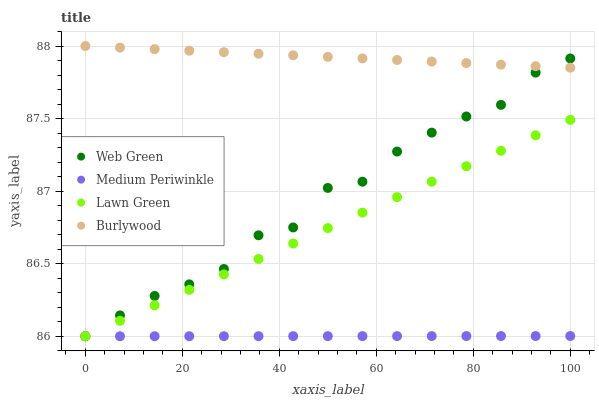Does Medium Periwinkle have the minimum area under the curve?
Answer yes or no. Yes. Does Burlywood have the maximum area under the curve?
Answer yes or no. Yes. Does Lawn Green have the minimum area under the curve?
Answer yes or no. No. Does Lawn Green have the maximum area under the curve?
Answer yes or no. No. Is Medium Periwinkle the smoothest?
Answer yes or no. Yes. Is Web Green the roughest?
Answer yes or no. Yes. Is Lawn Green the smoothest?
Answer yes or no. No. Is Lawn Green the roughest?
Answer yes or no. No. Does Lawn Green have the lowest value?
Answer yes or no. Yes. Does Burlywood have the highest value?
Answer yes or no. Yes. Does Lawn Green have the highest value?
Answer yes or no. No. Is Lawn Green less than Burlywood?
Answer yes or no. Yes. Is Burlywood greater than Medium Periwinkle?
Answer yes or no. Yes. Does Lawn Green intersect Medium Periwinkle?
Answer yes or no. Yes. Is Lawn Green less than Medium Periwinkle?
Answer yes or no. No. Is Lawn Green greater than Medium Periwinkle?
Answer yes or no. No. Does Lawn Green intersect Burlywood?
Answer yes or no. No. 